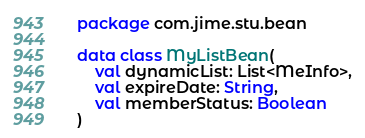Convert code to text. <code><loc_0><loc_0><loc_500><loc_500><_Kotlin_>package com.jime.stu.bean

data class MyListBean(
    val dynamicList: List<MeInfo>,
    val expireDate: String,
    val memberStatus: Boolean
)

</code> 